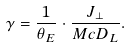Convert formula to latex. <formula><loc_0><loc_0><loc_500><loc_500>\gamma = \frac { 1 } { \theta _ { E } } \cdot \frac { J _ { \perp } } { M c D _ { L } } .</formula> 